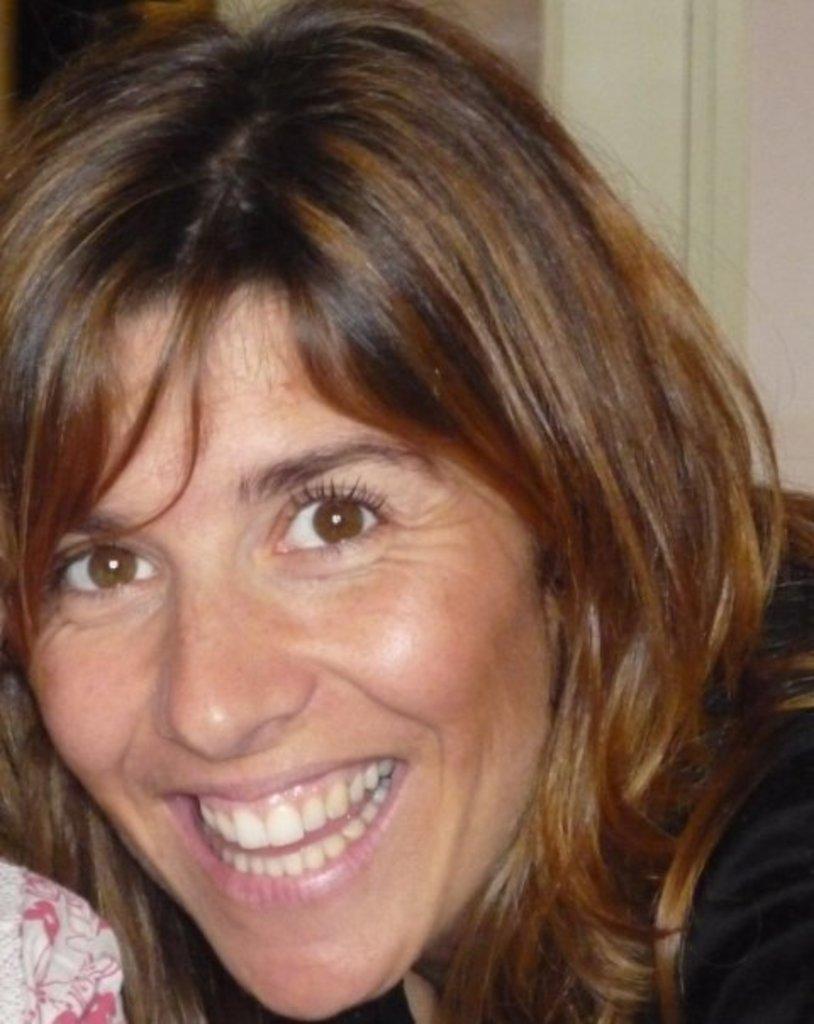Describe this image in one or two sentences. In the image there is a woman, she is laughing. Behind the woman there is a wall. 